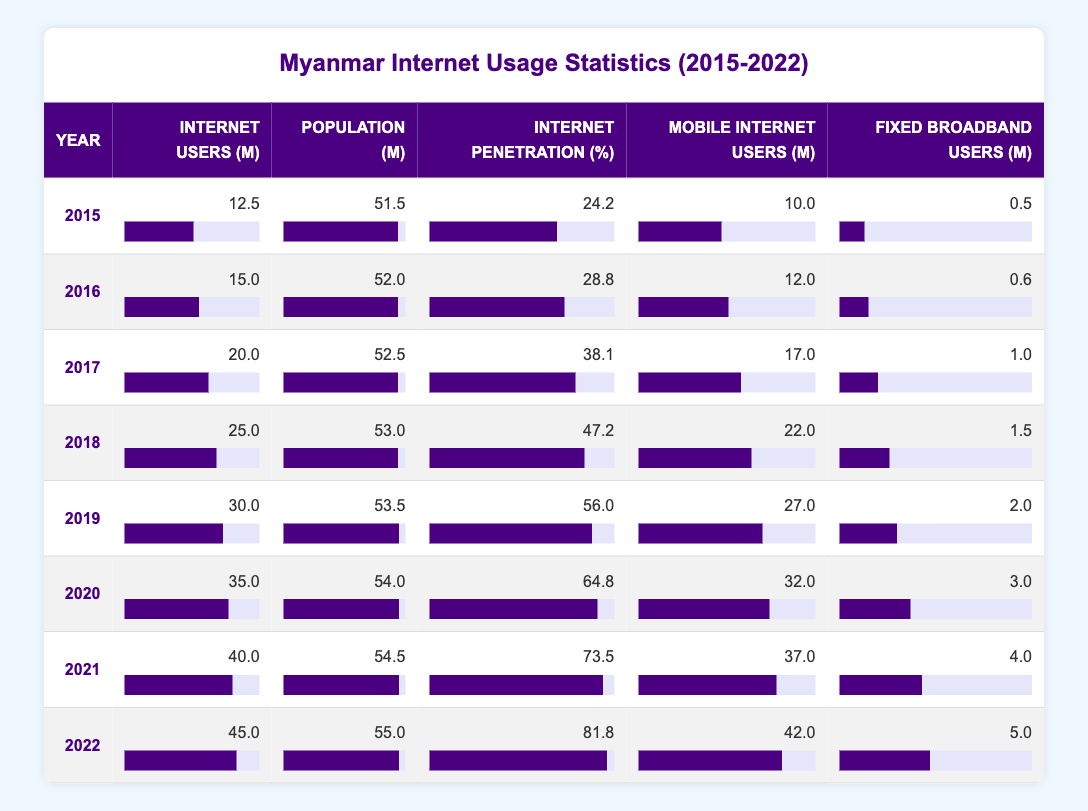What was the internet penetration percentage in Myanmar in 2019? By looking at the row for the year 2019, the internet penetration percentage is directly listed as 56.0.
Answer: 56.0 In which year did the number of internet users in millions first exceed 30 million? Referring to the table, we see that the number of internet users crossed 30 million in 2019, as the previous years (2015-2018) all show values below 30 million.
Answer: 2019 How many more million mobile internet users were there in 2022 compared to 2015? For 2022, there were 42.0 million mobile internet users and for 2015, there were 10.0 million. The difference is calculated as 42.0 - 10.0 = 32.0 million.
Answer: 32.0 million Is the population in Myanmar in 2021 higher than in 2015? Looking at the population figures, in 2021 the population is 54.5 million, whereas in 2015 it was 51.5 million. Since 54.5 is greater than 51.5, the statement is true.
Answer: Yes What was the average number of fixed broadband users from 2015 to 2022? To find the average, we first sum the fixed broadband users for each year: 0.5 + 0.6 + 1.0 + 1.5 + 2.0 + 3.0 + 4.0 + 5.0 = 18.6 million. Since there are 8 years in total, the average is 18.6 / 8 = 2.325 million.
Answer: 2.325 million In which year was the increase in internet users from the previous year the highest? By examining the internet users for each year, the increases are: 2.5 (2016-2015), 5.0 (2017-2016), 5.0 (2018-2017), 5.0 (2019-2018), 5.0 (2020-2019), 5.0 (2021-2020), and 5.0 (2022-2021). The highest increase is 5.0, which occurred from 2017 through 2022. Therefore, there is no one year with a higher increase than others during that period; it remained consistent.
Answer: 2017, 2018, 2019, 2020, 2021, 2022 Was the increase in mobile internet users from 2019 to 2020 greater than from 2018 to 2019? For 2019, mobile internet users were 27 million, and for 2020, they were 32 million. Thus, the increase from 2019 to 2020 is 32 - 27 = 5 million. For the previous year, 2018 had 22 million and 2019 had 27 million, so the increase was 27 - 22 = 5 million as well. Since both years see an equal increase of 5 million, the answer is no.
Answer: No What was the trend in internet penetration percentage from 2015 to 2022? Looking at the years, we can see the following percentages: 24.2 (2015), 28.8 (2016), 38.1 (2017), 47.2 (2018), 56.0 (2019), 64.8 (2020), 73.5 (2021), and 81.8 (2022). The percentages show a consistent increase annually, indicating a positive trend in internet penetration.
Answer: The trend is increasing 